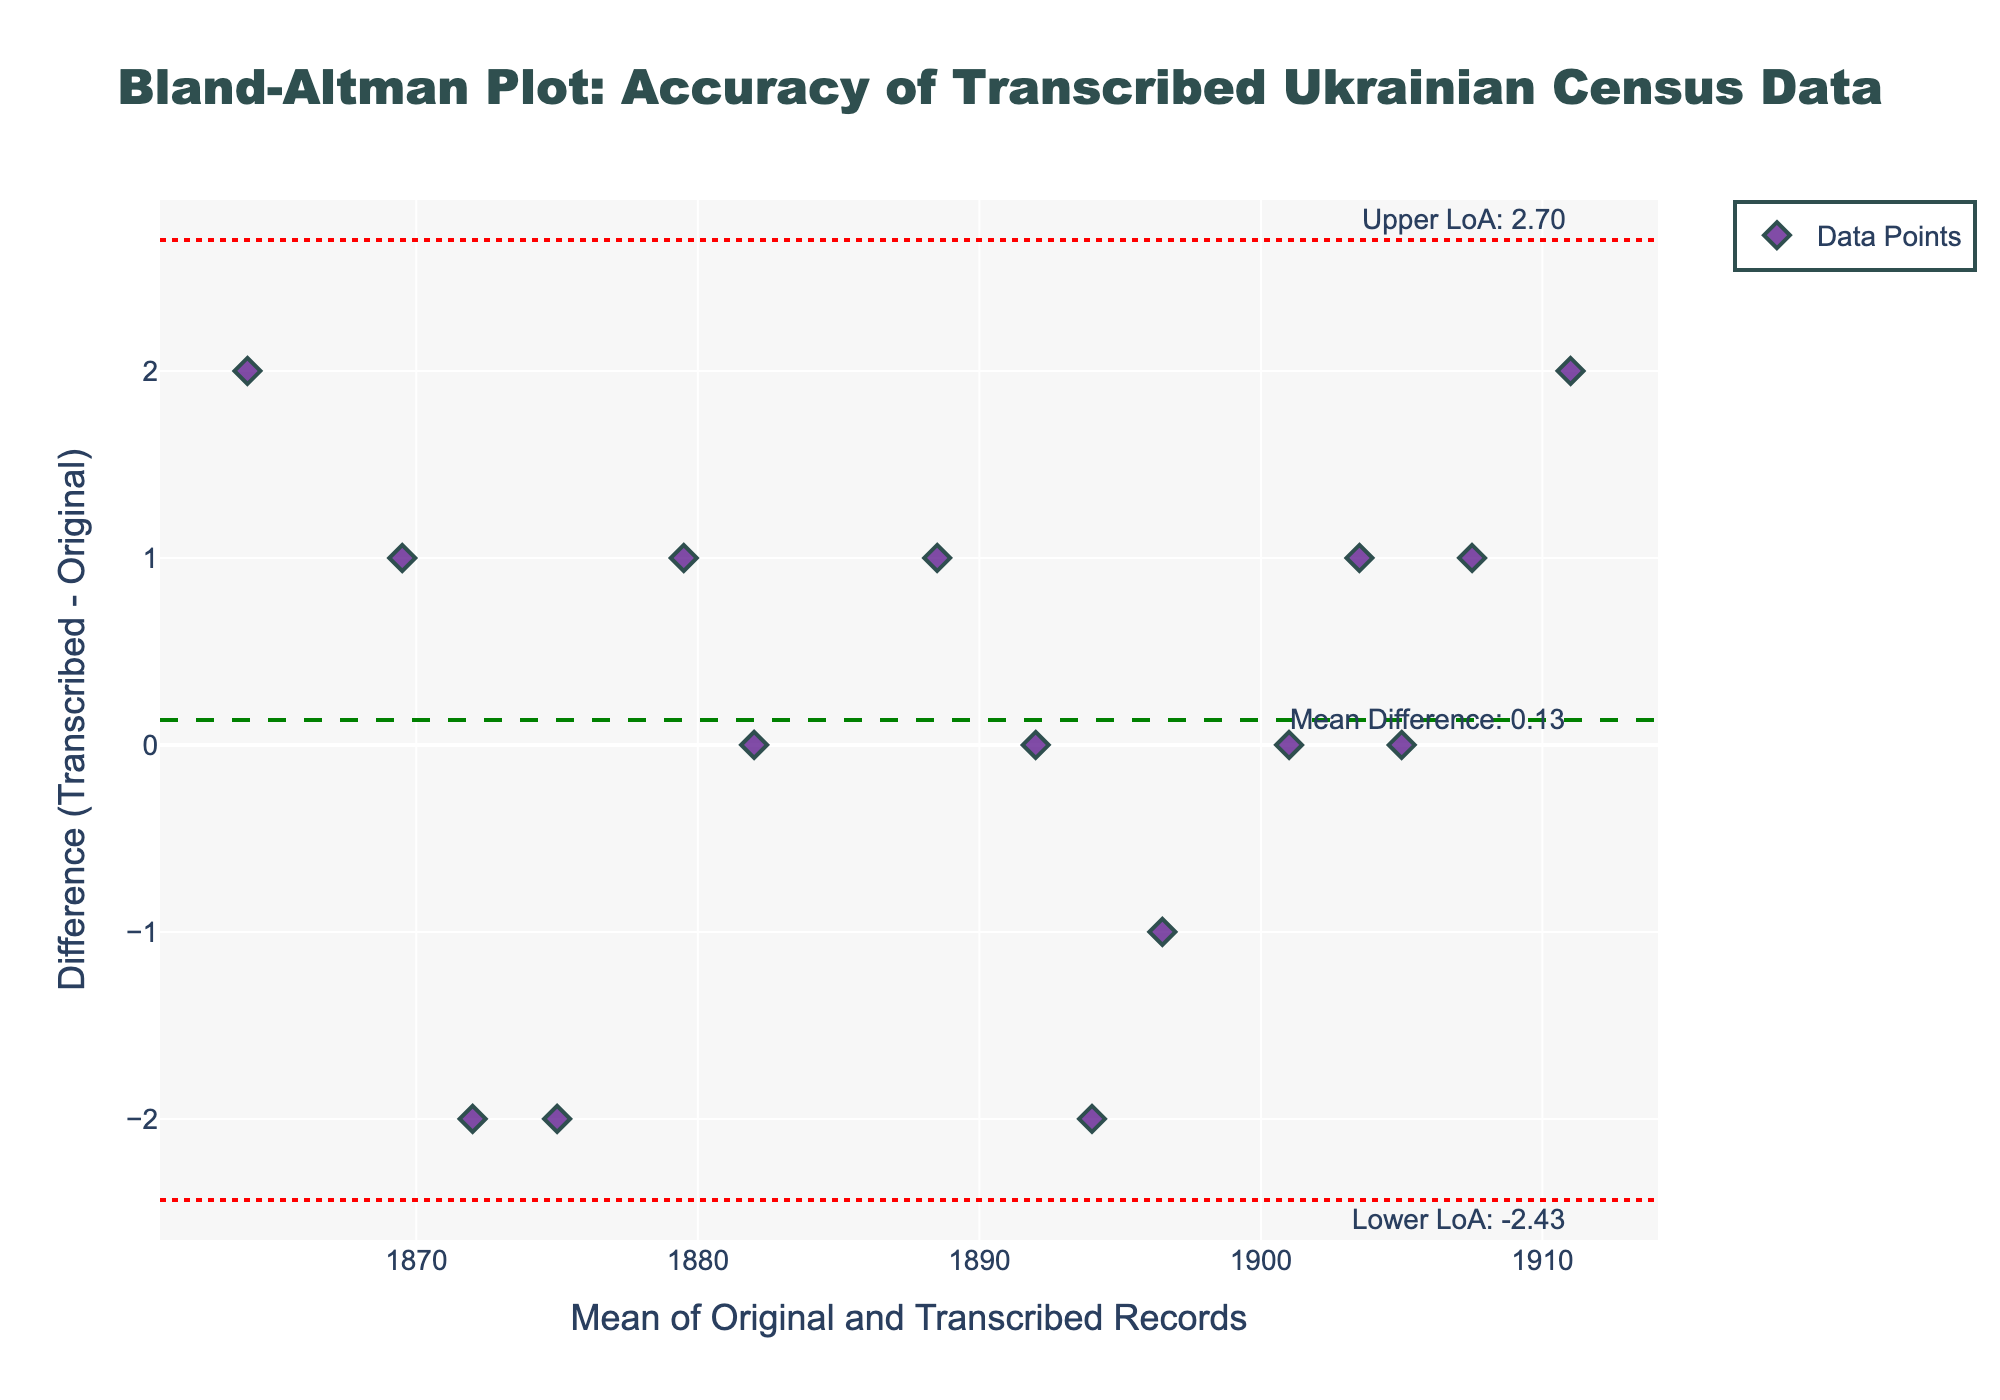what is the title of the plot? The title of the plot is typically located at the top center of the figure. In this case, it reads "Bland-Altman Plot: Accuracy of Transcribed Ukrainian Census Data"
Answer: Bland-Altman Plot: Accuracy of Transcribed Ukrainian Census Data How many data points are displayed in the plot? To find the number of data points, count the number of markers in the scatter plot. Each marker represents a single data point. There are 15 markers present.
Answer: 15 What is the mean difference between the original and transcribed records? The mean difference is identified by the green dashed horizontal line. The label next to this line reads "Mean Difference: ", followed by the value. The value is approximately 0.53.
Answer: 0.53 What are the upper and lower limits of agreement? The upper and lower limits of agreement are indicated by red dotted horizontal lines. They are also annotated next to the lines with the values. The upper limit is approximately 2.89 and the lower limit is approximately -1.83.
Answer: Upper: 2.89, Lower: -1.83 How many data points fall outside the limits of agreement? To determine the number of points outside the limits, count how many points fall above the upper limit and below the lower limit. There are no data points outside the limits of agreement in this plot.
Answer: 0 What is the difference for the data point with the largest mean value of original and transcribed records? The data point with the largest mean value is at the rightmost end of the x-axis. The mean value for this point is (1910 + 1912) / 2 = 1911. The corresponding difference is 2 (as indicated by its position relative to the y-axis).
Answer: 2 How does the difference change as the mean value increases? To understand the trend, observe the spread of the data points along the x-axis. There is no clear trend indicating that the difference increases or decreases consistently with the mean value in this plot.
Answer: No clear trend Which record has the highest positive difference? The highest positive difference can be identified by the marker farthest above the y=0 line. The record with the highest positive difference has a mean value of (1863 + 1865) / 2 = 1864 and a difference of 2.
Answer: The record with a mean of 1864 What observation can be made about the mean difference and the zero line? The mean difference line (green dashed) is slightly above the zero line, indicating a small positive bias where transcribed records tend to be slightly higher than original records.
Answer: Positive bias How consistent are the transcriptions with the original records? Based on the Bland-Altman plot, most data points lie within the limits of agreement, indicating that the transcriptions are fairly consistent with the original records with only minor differences.
Answer: Fairly consistent 